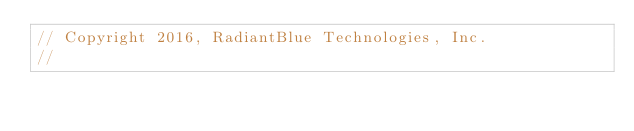Convert code to text. <code><loc_0><loc_0><loc_500><loc_500><_Go_>// Copyright 2016, RadiantBlue Technologies, Inc.
//</code> 